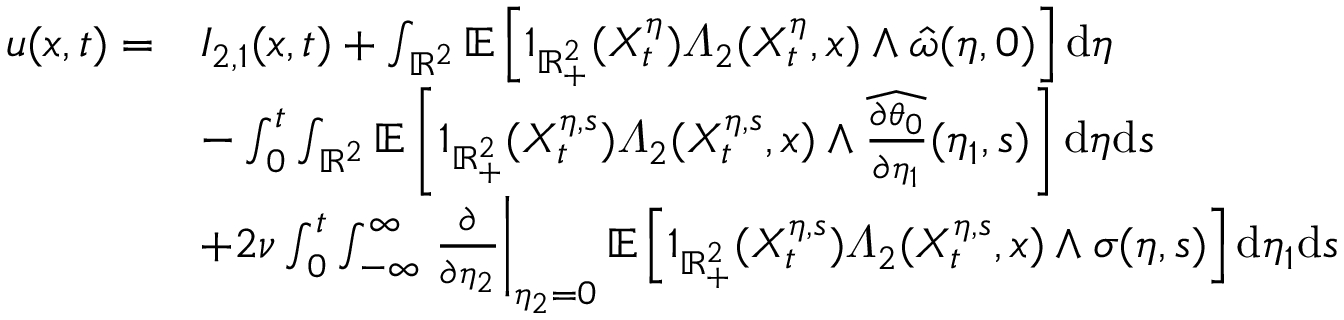<formula> <loc_0><loc_0><loc_500><loc_500>\begin{array} { r l } { u ( x , t ) = } & { I _ { 2 , 1 } ( x , t ) + \int _ { \mathbb { R } ^ { 2 } } \mathbb { E } \left [ 1 _ { \mathbb { R } _ { + } ^ { 2 } } ( X _ { t } ^ { \eta } ) \varLambda _ { 2 } ( X _ { t } ^ { \eta } , x ) \wedge \hat { \omega } ( \eta , 0 ) \right ] d \eta } \\ & { - \int _ { 0 } ^ { t } \int _ { \mathbb { R } ^ { 2 } } \mathbb { E } \left [ 1 _ { \mathbb { R } _ { + } ^ { 2 } } ( X _ { t } ^ { \eta , s } ) \varLambda _ { 2 } ( X _ { t } ^ { \eta , s } , x ) \wedge \widehat { \frac { \partial \theta _ { 0 } } { \partial \eta _ { 1 } } } ( \eta _ { 1 } , s ) \right ] d \eta d s } \\ & { + 2 \nu \int _ { 0 } ^ { t } \int _ { - \infty } ^ { \infty } \frac { \partial } { \partial \eta _ { 2 } } \right | _ { \eta _ { 2 } = 0 } \mathbb { E } \left [ 1 _ { \mathbb { R } _ { + } ^ { 2 } } ( X _ { t } ^ { \eta , s } ) \varLambda _ { 2 } ( X _ { t } ^ { \eta , s } , x ) \wedge \sigma ( \eta , s ) \right ] d \eta _ { 1 } d s } \end{array}</formula> 